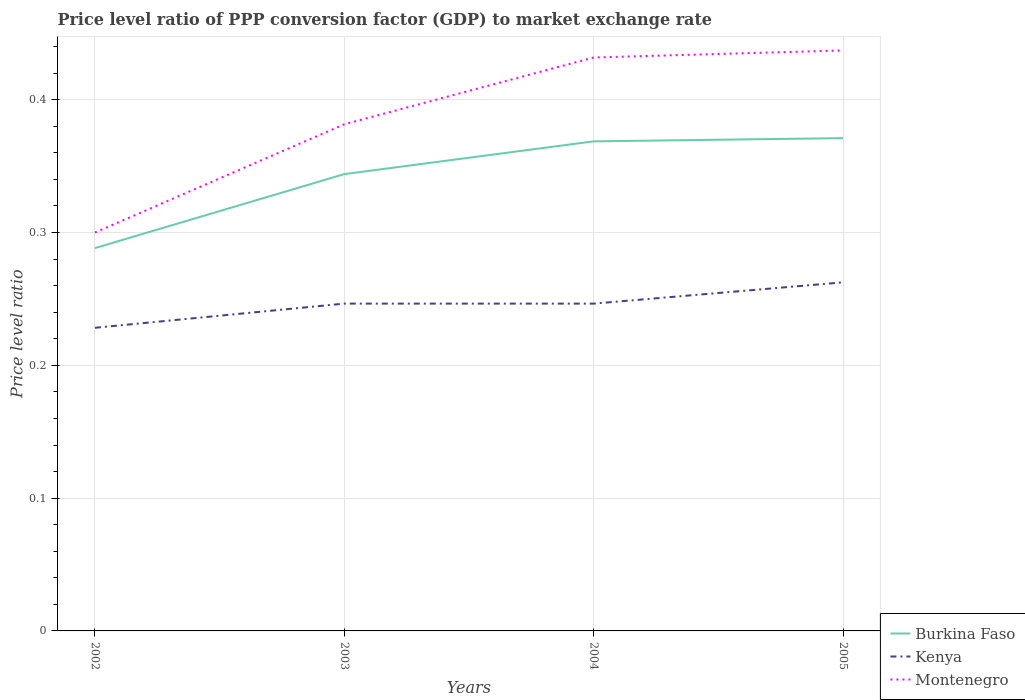Across all years, what is the maximum price level ratio in Kenya?
Ensure brevity in your answer.  0.23. In which year was the price level ratio in Montenegro maximum?
Your answer should be very brief. 2002. What is the total price level ratio in Montenegro in the graph?
Provide a short and direct response. -0.05. What is the difference between the highest and the second highest price level ratio in Montenegro?
Keep it short and to the point. 0.14. How many lines are there?
Your answer should be compact. 3. Does the graph contain any zero values?
Offer a terse response. No. Does the graph contain grids?
Provide a short and direct response. Yes. Where does the legend appear in the graph?
Offer a terse response. Bottom right. How many legend labels are there?
Keep it short and to the point. 3. What is the title of the graph?
Your response must be concise. Price level ratio of PPP conversion factor (GDP) to market exchange rate. Does "Euro area" appear as one of the legend labels in the graph?
Ensure brevity in your answer.  No. What is the label or title of the X-axis?
Provide a short and direct response. Years. What is the label or title of the Y-axis?
Keep it short and to the point. Price level ratio. What is the Price level ratio in Burkina Faso in 2002?
Keep it short and to the point. 0.29. What is the Price level ratio of Kenya in 2002?
Your answer should be very brief. 0.23. What is the Price level ratio in Montenegro in 2002?
Your response must be concise. 0.3. What is the Price level ratio in Burkina Faso in 2003?
Provide a short and direct response. 0.34. What is the Price level ratio in Kenya in 2003?
Offer a terse response. 0.25. What is the Price level ratio in Montenegro in 2003?
Your response must be concise. 0.38. What is the Price level ratio of Burkina Faso in 2004?
Make the answer very short. 0.37. What is the Price level ratio of Kenya in 2004?
Give a very brief answer. 0.25. What is the Price level ratio in Montenegro in 2004?
Your answer should be compact. 0.43. What is the Price level ratio of Burkina Faso in 2005?
Provide a short and direct response. 0.37. What is the Price level ratio in Kenya in 2005?
Give a very brief answer. 0.26. What is the Price level ratio of Montenegro in 2005?
Provide a succinct answer. 0.44. Across all years, what is the maximum Price level ratio of Burkina Faso?
Provide a succinct answer. 0.37. Across all years, what is the maximum Price level ratio of Kenya?
Provide a short and direct response. 0.26. Across all years, what is the maximum Price level ratio in Montenegro?
Keep it short and to the point. 0.44. Across all years, what is the minimum Price level ratio in Burkina Faso?
Offer a terse response. 0.29. Across all years, what is the minimum Price level ratio of Kenya?
Give a very brief answer. 0.23. Across all years, what is the minimum Price level ratio in Montenegro?
Provide a succinct answer. 0.3. What is the total Price level ratio of Burkina Faso in the graph?
Offer a terse response. 1.37. What is the total Price level ratio of Kenya in the graph?
Keep it short and to the point. 0.98. What is the total Price level ratio in Montenegro in the graph?
Keep it short and to the point. 1.55. What is the difference between the Price level ratio in Burkina Faso in 2002 and that in 2003?
Your answer should be compact. -0.06. What is the difference between the Price level ratio in Kenya in 2002 and that in 2003?
Your answer should be very brief. -0.02. What is the difference between the Price level ratio of Montenegro in 2002 and that in 2003?
Ensure brevity in your answer.  -0.08. What is the difference between the Price level ratio of Burkina Faso in 2002 and that in 2004?
Ensure brevity in your answer.  -0.08. What is the difference between the Price level ratio of Kenya in 2002 and that in 2004?
Your response must be concise. -0.02. What is the difference between the Price level ratio in Montenegro in 2002 and that in 2004?
Your answer should be very brief. -0.13. What is the difference between the Price level ratio of Burkina Faso in 2002 and that in 2005?
Your answer should be very brief. -0.08. What is the difference between the Price level ratio in Kenya in 2002 and that in 2005?
Your answer should be compact. -0.03. What is the difference between the Price level ratio of Montenegro in 2002 and that in 2005?
Offer a very short reply. -0.14. What is the difference between the Price level ratio in Burkina Faso in 2003 and that in 2004?
Give a very brief answer. -0.02. What is the difference between the Price level ratio of Montenegro in 2003 and that in 2004?
Make the answer very short. -0.05. What is the difference between the Price level ratio in Burkina Faso in 2003 and that in 2005?
Ensure brevity in your answer.  -0.03. What is the difference between the Price level ratio in Kenya in 2003 and that in 2005?
Give a very brief answer. -0.02. What is the difference between the Price level ratio of Montenegro in 2003 and that in 2005?
Offer a very short reply. -0.06. What is the difference between the Price level ratio in Burkina Faso in 2004 and that in 2005?
Make the answer very short. -0. What is the difference between the Price level ratio of Kenya in 2004 and that in 2005?
Provide a short and direct response. -0.02. What is the difference between the Price level ratio of Montenegro in 2004 and that in 2005?
Keep it short and to the point. -0.01. What is the difference between the Price level ratio of Burkina Faso in 2002 and the Price level ratio of Kenya in 2003?
Offer a very short reply. 0.04. What is the difference between the Price level ratio in Burkina Faso in 2002 and the Price level ratio in Montenegro in 2003?
Offer a terse response. -0.09. What is the difference between the Price level ratio of Kenya in 2002 and the Price level ratio of Montenegro in 2003?
Your response must be concise. -0.15. What is the difference between the Price level ratio in Burkina Faso in 2002 and the Price level ratio in Kenya in 2004?
Give a very brief answer. 0.04. What is the difference between the Price level ratio of Burkina Faso in 2002 and the Price level ratio of Montenegro in 2004?
Your answer should be compact. -0.14. What is the difference between the Price level ratio in Kenya in 2002 and the Price level ratio in Montenegro in 2004?
Give a very brief answer. -0.2. What is the difference between the Price level ratio of Burkina Faso in 2002 and the Price level ratio of Kenya in 2005?
Offer a very short reply. 0.03. What is the difference between the Price level ratio in Burkina Faso in 2002 and the Price level ratio in Montenegro in 2005?
Offer a very short reply. -0.15. What is the difference between the Price level ratio of Kenya in 2002 and the Price level ratio of Montenegro in 2005?
Your answer should be compact. -0.21. What is the difference between the Price level ratio of Burkina Faso in 2003 and the Price level ratio of Kenya in 2004?
Offer a very short reply. 0.1. What is the difference between the Price level ratio in Burkina Faso in 2003 and the Price level ratio in Montenegro in 2004?
Your answer should be very brief. -0.09. What is the difference between the Price level ratio of Kenya in 2003 and the Price level ratio of Montenegro in 2004?
Give a very brief answer. -0.19. What is the difference between the Price level ratio of Burkina Faso in 2003 and the Price level ratio of Kenya in 2005?
Give a very brief answer. 0.08. What is the difference between the Price level ratio in Burkina Faso in 2003 and the Price level ratio in Montenegro in 2005?
Your answer should be very brief. -0.09. What is the difference between the Price level ratio of Kenya in 2003 and the Price level ratio of Montenegro in 2005?
Provide a succinct answer. -0.19. What is the difference between the Price level ratio in Burkina Faso in 2004 and the Price level ratio in Kenya in 2005?
Your answer should be very brief. 0.11. What is the difference between the Price level ratio of Burkina Faso in 2004 and the Price level ratio of Montenegro in 2005?
Keep it short and to the point. -0.07. What is the difference between the Price level ratio in Kenya in 2004 and the Price level ratio in Montenegro in 2005?
Offer a terse response. -0.19. What is the average Price level ratio of Burkina Faso per year?
Provide a short and direct response. 0.34. What is the average Price level ratio in Kenya per year?
Keep it short and to the point. 0.25. What is the average Price level ratio of Montenegro per year?
Provide a succinct answer. 0.39. In the year 2002, what is the difference between the Price level ratio in Burkina Faso and Price level ratio in Montenegro?
Your answer should be compact. -0.01. In the year 2002, what is the difference between the Price level ratio of Kenya and Price level ratio of Montenegro?
Make the answer very short. -0.07. In the year 2003, what is the difference between the Price level ratio of Burkina Faso and Price level ratio of Kenya?
Your answer should be very brief. 0.1. In the year 2003, what is the difference between the Price level ratio of Burkina Faso and Price level ratio of Montenegro?
Make the answer very short. -0.04. In the year 2003, what is the difference between the Price level ratio of Kenya and Price level ratio of Montenegro?
Provide a succinct answer. -0.14. In the year 2004, what is the difference between the Price level ratio in Burkina Faso and Price level ratio in Kenya?
Ensure brevity in your answer.  0.12. In the year 2004, what is the difference between the Price level ratio of Burkina Faso and Price level ratio of Montenegro?
Your response must be concise. -0.06. In the year 2004, what is the difference between the Price level ratio of Kenya and Price level ratio of Montenegro?
Your answer should be very brief. -0.19. In the year 2005, what is the difference between the Price level ratio of Burkina Faso and Price level ratio of Kenya?
Your answer should be compact. 0.11. In the year 2005, what is the difference between the Price level ratio in Burkina Faso and Price level ratio in Montenegro?
Your answer should be very brief. -0.07. In the year 2005, what is the difference between the Price level ratio of Kenya and Price level ratio of Montenegro?
Your response must be concise. -0.17. What is the ratio of the Price level ratio in Burkina Faso in 2002 to that in 2003?
Give a very brief answer. 0.84. What is the ratio of the Price level ratio in Kenya in 2002 to that in 2003?
Your response must be concise. 0.93. What is the ratio of the Price level ratio of Montenegro in 2002 to that in 2003?
Offer a very short reply. 0.79. What is the ratio of the Price level ratio in Burkina Faso in 2002 to that in 2004?
Your answer should be very brief. 0.78. What is the ratio of the Price level ratio of Kenya in 2002 to that in 2004?
Ensure brevity in your answer.  0.93. What is the ratio of the Price level ratio in Montenegro in 2002 to that in 2004?
Make the answer very short. 0.69. What is the ratio of the Price level ratio of Burkina Faso in 2002 to that in 2005?
Keep it short and to the point. 0.78. What is the ratio of the Price level ratio of Kenya in 2002 to that in 2005?
Provide a short and direct response. 0.87. What is the ratio of the Price level ratio of Montenegro in 2002 to that in 2005?
Your answer should be compact. 0.69. What is the ratio of the Price level ratio in Burkina Faso in 2003 to that in 2004?
Your answer should be compact. 0.93. What is the ratio of the Price level ratio in Montenegro in 2003 to that in 2004?
Keep it short and to the point. 0.88. What is the ratio of the Price level ratio in Burkina Faso in 2003 to that in 2005?
Your answer should be compact. 0.93. What is the ratio of the Price level ratio in Kenya in 2003 to that in 2005?
Give a very brief answer. 0.94. What is the ratio of the Price level ratio in Montenegro in 2003 to that in 2005?
Make the answer very short. 0.87. What is the ratio of the Price level ratio of Burkina Faso in 2004 to that in 2005?
Ensure brevity in your answer.  0.99. What is the ratio of the Price level ratio of Kenya in 2004 to that in 2005?
Your answer should be very brief. 0.94. What is the ratio of the Price level ratio of Montenegro in 2004 to that in 2005?
Provide a succinct answer. 0.99. What is the difference between the highest and the second highest Price level ratio of Burkina Faso?
Provide a succinct answer. 0. What is the difference between the highest and the second highest Price level ratio in Kenya?
Your answer should be compact. 0.02. What is the difference between the highest and the second highest Price level ratio of Montenegro?
Provide a short and direct response. 0.01. What is the difference between the highest and the lowest Price level ratio of Burkina Faso?
Make the answer very short. 0.08. What is the difference between the highest and the lowest Price level ratio in Kenya?
Provide a short and direct response. 0.03. What is the difference between the highest and the lowest Price level ratio in Montenegro?
Your answer should be very brief. 0.14. 